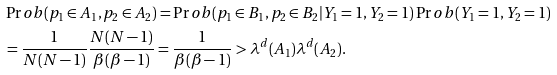Convert formula to latex. <formula><loc_0><loc_0><loc_500><loc_500>& \Pr o b ( p _ { 1 } \in A _ { 1 } , p _ { 2 } \in A _ { 2 } ) = \Pr o b ( p _ { 1 } \in B _ { 1 } , p _ { 2 } \in B _ { 2 } | Y _ { 1 } = 1 , Y _ { 2 } = 1 ) \Pr o b ( Y _ { 1 } = 1 , Y _ { 2 } = 1 ) \\ & = \frac { 1 } { N ( N - 1 ) } \frac { N ( N - 1 ) } { \beta ( \beta - 1 ) } = \frac { 1 } { \beta ( \beta - 1 ) } > \lambda ^ { d } ( A _ { 1 } ) \lambda ^ { d } ( A _ { 2 } ) .</formula> 